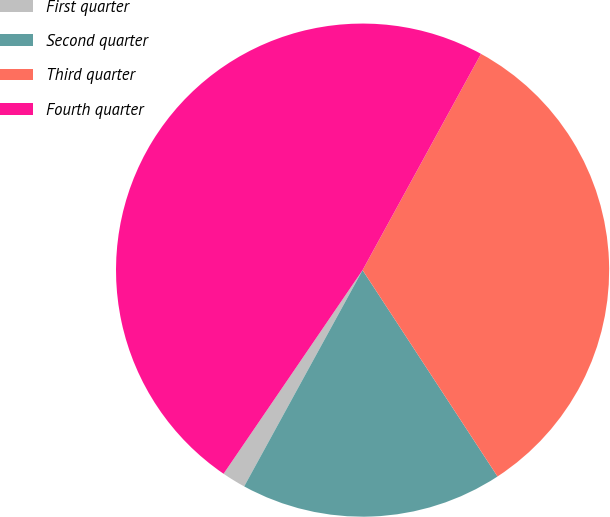Convert chart. <chart><loc_0><loc_0><loc_500><loc_500><pie_chart><fcel>First quarter<fcel>Second quarter<fcel>Third quarter<fcel>Fourth quarter<nl><fcel>1.56%<fcel>17.19%<fcel>32.81%<fcel>48.44%<nl></chart> 